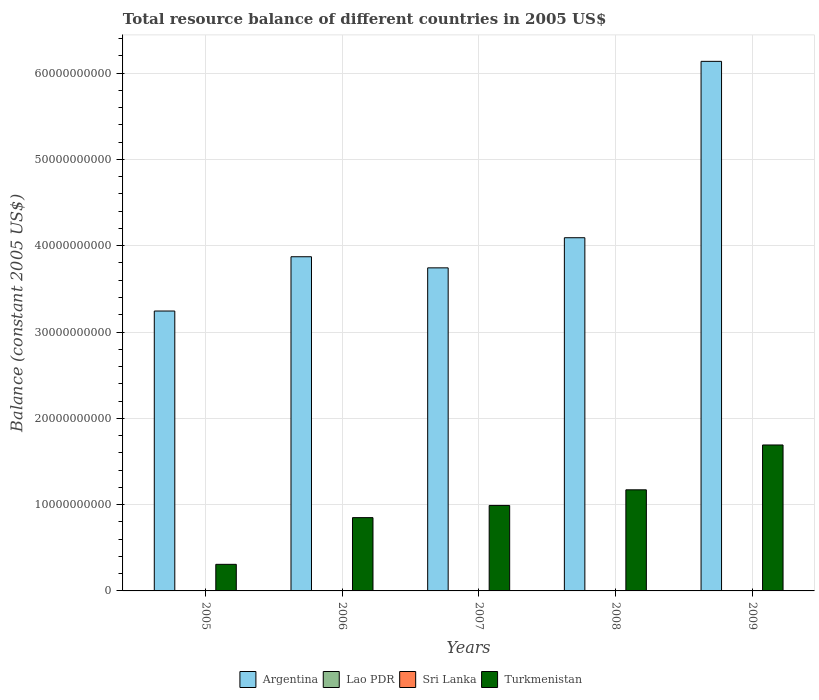How many different coloured bars are there?
Provide a short and direct response. 2. How many groups of bars are there?
Your answer should be compact. 5. Are the number of bars on each tick of the X-axis equal?
Offer a terse response. Yes. What is the total resource balance in Sri Lanka in 2008?
Give a very brief answer. 0. Across all years, what is the maximum total resource balance in Argentina?
Your response must be concise. 6.14e+1. In which year was the total resource balance in Argentina maximum?
Provide a succinct answer. 2009. What is the total total resource balance in Lao PDR in the graph?
Your answer should be compact. 0. What is the difference between the total resource balance in Turkmenistan in 2006 and that in 2008?
Make the answer very short. -3.22e+09. What is the difference between the total resource balance in Lao PDR in 2007 and the total resource balance in Sri Lanka in 2005?
Provide a succinct answer. 0. What is the average total resource balance in Turkmenistan per year?
Provide a short and direct response. 1.00e+1. In the year 2009, what is the difference between the total resource balance in Argentina and total resource balance in Turkmenistan?
Make the answer very short. 4.45e+1. What is the ratio of the total resource balance in Turkmenistan in 2007 to that in 2009?
Make the answer very short. 0.59. Is the total resource balance in Argentina in 2006 less than that in 2007?
Keep it short and to the point. No. What is the difference between the highest and the second highest total resource balance in Turkmenistan?
Your response must be concise. 5.20e+09. What is the difference between the highest and the lowest total resource balance in Argentina?
Your answer should be very brief. 2.89e+1. In how many years, is the total resource balance in Turkmenistan greater than the average total resource balance in Turkmenistan taken over all years?
Offer a terse response. 2. Is the sum of the total resource balance in Argentina in 2005 and 2009 greater than the maximum total resource balance in Turkmenistan across all years?
Make the answer very short. Yes. Is it the case that in every year, the sum of the total resource balance in Sri Lanka and total resource balance in Lao PDR is greater than the sum of total resource balance in Argentina and total resource balance in Turkmenistan?
Your answer should be compact. No. Is it the case that in every year, the sum of the total resource balance in Turkmenistan and total resource balance in Sri Lanka is greater than the total resource balance in Argentina?
Your answer should be compact. No. How many years are there in the graph?
Your response must be concise. 5. What is the difference between two consecutive major ticks on the Y-axis?
Ensure brevity in your answer.  1.00e+1. How are the legend labels stacked?
Keep it short and to the point. Horizontal. What is the title of the graph?
Provide a succinct answer. Total resource balance of different countries in 2005 US$. What is the label or title of the X-axis?
Offer a terse response. Years. What is the label or title of the Y-axis?
Your answer should be compact. Balance (constant 2005 US$). What is the Balance (constant 2005 US$) of Argentina in 2005?
Make the answer very short. 3.24e+1. What is the Balance (constant 2005 US$) in Sri Lanka in 2005?
Give a very brief answer. 0. What is the Balance (constant 2005 US$) of Turkmenistan in 2005?
Your answer should be very brief. 3.08e+09. What is the Balance (constant 2005 US$) of Argentina in 2006?
Your answer should be compact. 3.87e+1. What is the Balance (constant 2005 US$) of Sri Lanka in 2006?
Ensure brevity in your answer.  0. What is the Balance (constant 2005 US$) of Turkmenistan in 2006?
Offer a very short reply. 8.49e+09. What is the Balance (constant 2005 US$) in Argentina in 2007?
Provide a succinct answer. 3.74e+1. What is the Balance (constant 2005 US$) in Turkmenistan in 2007?
Offer a terse response. 9.91e+09. What is the Balance (constant 2005 US$) of Argentina in 2008?
Make the answer very short. 4.09e+1. What is the Balance (constant 2005 US$) of Turkmenistan in 2008?
Offer a very short reply. 1.17e+1. What is the Balance (constant 2005 US$) of Argentina in 2009?
Provide a succinct answer. 6.14e+1. What is the Balance (constant 2005 US$) in Lao PDR in 2009?
Offer a very short reply. 0. What is the Balance (constant 2005 US$) of Sri Lanka in 2009?
Keep it short and to the point. 0. What is the Balance (constant 2005 US$) in Turkmenistan in 2009?
Make the answer very short. 1.69e+1. Across all years, what is the maximum Balance (constant 2005 US$) in Argentina?
Offer a very short reply. 6.14e+1. Across all years, what is the maximum Balance (constant 2005 US$) of Turkmenistan?
Your answer should be very brief. 1.69e+1. Across all years, what is the minimum Balance (constant 2005 US$) in Argentina?
Keep it short and to the point. 3.24e+1. Across all years, what is the minimum Balance (constant 2005 US$) of Turkmenistan?
Give a very brief answer. 3.08e+09. What is the total Balance (constant 2005 US$) in Argentina in the graph?
Ensure brevity in your answer.  2.11e+11. What is the total Balance (constant 2005 US$) of Turkmenistan in the graph?
Your answer should be very brief. 5.01e+1. What is the difference between the Balance (constant 2005 US$) in Argentina in 2005 and that in 2006?
Keep it short and to the point. -6.29e+09. What is the difference between the Balance (constant 2005 US$) of Turkmenistan in 2005 and that in 2006?
Your answer should be compact. -5.41e+09. What is the difference between the Balance (constant 2005 US$) in Argentina in 2005 and that in 2007?
Keep it short and to the point. -5.00e+09. What is the difference between the Balance (constant 2005 US$) of Turkmenistan in 2005 and that in 2007?
Give a very brief answer. -6.83e+09. What is the difference between the Balance (constant 2005 US$) of Argentina in 2005 and that in 2008?
Make the answer very short. -8.49e+09. What is the difference between the Balance (constant 2005 US$) of Turkmenistan in 2005 and that in 2008?
Ensure brevity in your answer.  -8.63e+09. What is the difference between the Balance (constant 2005 US$) in Argentina in 2005 and that in 2009?
Provide a short and direct response. -2.89e+1. What is the difference between the Balance (constant 2005 US$) of Turkmenistan in 2005 and that in 2009?
Provide a short and direct response. -1.38e+1. What is the difference between the Balance (constant 2005 US$) of Argentina in 2006 and that in 2007?
Your answer should be very brief. 1.29e+09. What is the difference between the Balance (constant 2005 US$) of Turkmenistan in 2006 and that in 2007?
Provide a succinct answer. -1.41e+09. What is the difference between the Balance (constant 2005 US$) of Argentina in 2006 and that in 2008?
Offer a very short reply. -2.20e+09. What is the difference between the Balance (constant 2005 US$) in Turkmenistan in 2006 and that in 2008?
Give a very brief answer. -3.22e+09. What is the difference between the Balance (constant 2005 US$) in Argentina in 2006 and that in 2009?
Your answer should be compact. -2.26e+1. What is the difference between the Balance (constant 2005 US$) of Turkmenistan in 2006 and that in 2009?
Keep it short and to the point. -8.42e+09. What is the difference between the Balance (constant 2005 US$) in Argentina in 2007 and that in 2008?
Your answer should be compact. -3.49e+09. What is the difference between the Balance (constant 2005 US$) of Turkmenistan in 2007 and that in 2008?
Your answer should be very brief. -1.81e+09. What is the difference between the Balance (constant 2005 US$) in Argentina in 2007 and that in 2009?
Provide a succinct answer. -2.39e+1. What is the difference between the Balance (constant 2005 US$) in Turkmenistan in 2007 and that in 2009?
Provide a succinct answer. -7.00e+09. What is the difference between the Balance (constant 2005 US$) of Argentina in 2008 and that in 2009?
Ensure brevity in your answer.  -2.04e+1. What is the difference between the Balance (constant 2005 US$) of Turkmenistan in 2008 and that in 2009?
Provide a succinct answer. -5.20e+09. What is the difference between the Balance (constant 2005 US$) of Argentina in 2005 and the Balance (constant 2005 US$) of Turkmenistan in 2006?
Offer a terse response. 2.39e+1. What is the difference between the Balance (constant 2005 US$) in Argentina in 2005 and the Balance (constant 2005 US$) in Turkmenistan in 2007?
Give a very brief answer. 2.25e+1. What is the difference between the Balance (constant 2005 US$) of Argentina in 2005 and the Balance (constant 2005 US$) of Turkmenistan in 2008?
Provide a short and direct response. 2.07e+1. What is the difference between the Balance (constant 2005 US$) in Argentina in 2005 and the Balance (constant 2005 US$) in Turkmenistan in 2009?
Your answer should be very brief. 1.55e+1. What is the difference between the Balance (constant 2005 US$) in Argentina in 2006 and the Balance (constant 2005 US$) in Turkmenistan in 2007?
Offer a terse response. 2.88e+1. What is the difference between the Balance (constant 2005 US$) in Argentina in 2006 and the Balance (constant 2005 US$) in Turkmenistan in 2008?
Your response must be concise. 2.70e+1. What is the difference between the Balance (constant 2005 US$) in Argentina in 2006 and the Balance (constant 2005 US$) in Turkmenistan in 2009?
Your answer should be compact. 2.18e+1. What is the difference between the Balance (constant 2005 US$) of Argentina in 2007 and the Balance (constant 2005 US$) of Turkmenistan in 2008?
Offer a terse response. 2.57e+1. What is the difference between the Balance (constant 2005 US$) in Argentina in 2007 and the Balance (constant 2005 US$) in Turkmenistan in 2009?
Provide a succinct answer. 2.05e+1. What is the difference between the Balance (constant 2005 US$) of Argentina in 2008 and the Balance (constant 2005 US$) of Turkmenistan in 2009?
Provide a succinct answer. 2.40e+1. What is the average Balance (constant 2005 US$) of Argentina per year?
Give a very brief answer. 4.22e+1. What is the average Balance (constant 2005 US$) of Lao PDR per year?
Your response must be concise. 0. What is the average Balance (constant 2005 US$) in Sri Lanka per year?
Offer a terse response. 0. What is the average Balance (constant 2005 US$) of Turkmenistan per year?
Your answer should be very brief. 1.00e+1. In the year 2005, what is the difference between the Balance (constant 2005 US$) in Argentina and Balance (constant 2005 US$) in Turkmenistan?
Your answer should be compact. 2.94e+1. In the year 2006, what is the difference between the Balance (constant 2005 US$) in Argentina and Balance (constant 2005 US$) in Turkmenistan?
Provide a short and direct response. 3.02e+1. In the year 2007, what is the difference between the Balance (constant 2005 US$) in Argentina and Balance (constant 2005 US$) in Turkmenistan?
Offer a very short reply. 2.75e+1. In the year 2008, what is the difference between the Balance (constant 2005 US$) of Argentina and Balance (constant 2005 US$) of Turkmenistan?
Provide a short and direct response. 2.92e+1. In the year 2009, what is the difference between the Balance (constant 2005 US$) in Argentina and Balance (constant 2005 US$) in Turkmenistan?
Your answer should be very brief. 4.45e+1. What is the ratio of the Balance (constant 2005 US$) in Argentina in 2005 to that in 2006?
Your response must be concise. 0.84. What is the ratio of the Balance (constant 2005 US$) of Turkmenistan in 2005 to that in 2006?
Offer a terse response. 0.36. What is the ratio of the Balance (constant 2005 US$) in Argentina in 2005 to that in 2007?
Your answer should be compact. 0.87. What is the ratio of the Balance (constant 2005 US$) of Turkmenistan in 2005 to that in 2007?
Give a very brief answer. 0.31. What is the ratio of the Balance (constant 2005 US$) of Argentina in 2005 to that in 2008?
Provide a succinct answer. 0.79. What is the ratio of the Balance (constant 2005 US$) of Turkmenistan in 2005 to that in 2008?
Ensure brevity in your answer.  0.26. What is the ratio of the Balance (constant 2005 US$) of Argentina in 2005 to that in 2009?
Provide a succinct answer. 0.53. What is the ratio of the Balance (constant 2005 US$) of Turkmenistan in 2005 to that in 2009?
Give a very brief answer. 0.18. What is the ratio of the Balance (constant 2005 US$) of Argentina in 2006 to that in 2007?
Offer a very short reply. 1.03. What is the ratio of the Balance (constant 2005 US$) of Turkmenistan in 2006 to that in 2007?
Give a very brief answer. 0.86. What is the ratio of the Balance (constant 2005 US$) of Argentina in 2006 to that in 2008?
Offer a terse response. 0.95. What is the ratio of the Balance (constant 2005 US$) in Turkmenistan in 2006 to that in 2008?
Make the answer very short. 0.72. What is the ratio of the Balance (constant 2005 US$) of Argentina in 2006 to that in 2009?
Offer a very short reply. 0.63. What is the ratio of the Balance (constant 2005 US$) in Turkmenistan in 2006 to that in 2009?
Provide a short and direct response. 0.5. What is the ratio of the Balance (constant 2005 US$) of Argentina in 2007 to that in 2008?
Make the answer very short. 0.91. What is the ratio of the Balance (constant 2005 US$) in Turkmenistan in 2007 to that in 2008?
Make the answer very short. 0.85. What is the ratio of the Balance (constant 2005 US$) of Argentina in 2007 to that in 2009?
Offer a very short reply. 0.61. What is the ratio of the Balance (constant 2005 US$) of Turkmenistan in 2007 to that in 2009?
Your answer should be very brief. 0.59. What is the ratio of the Balance (constant 2005 US$) of Argentina in 2008 to that in 2009?
Your answer should be very brief. 0.67. What is the ratio of the Balance (constant 2005 US$) in Turkmenistan in 2008 to that in 2009?
Your answer should be compact. 0.69. What is the difference between the highest and the second highest Balance (constant 2005 US$) of Argentina?
Your answer should be very brief. 2.04e+1. What is the difference between the highest and the second highest Balance (constant 2005 US$) in Turkmenistan?
Offer a very short reply. 5.20e+09. What is the difference between the highest and the lowest Balance (constant 2005 US$) in Argentina?
Ensure brevity in your answer.  2.89e+1. What is the difference between the highest and the lowest Balance (constant 2005 US$) in Turkmenistan?
Provide a succinct answer. 1.38e+1. 